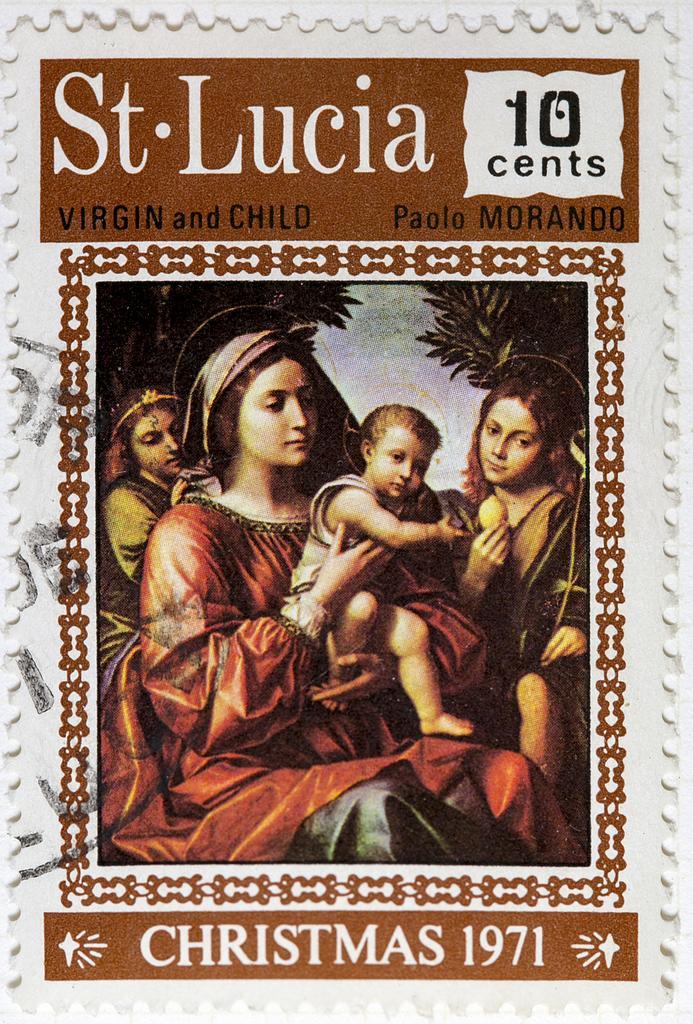Could you give a brief overview of what you see in this image? This is the image of posture with some text at top and bottom. There is a woman holding a kid, and two other people, trees in the foreground. 